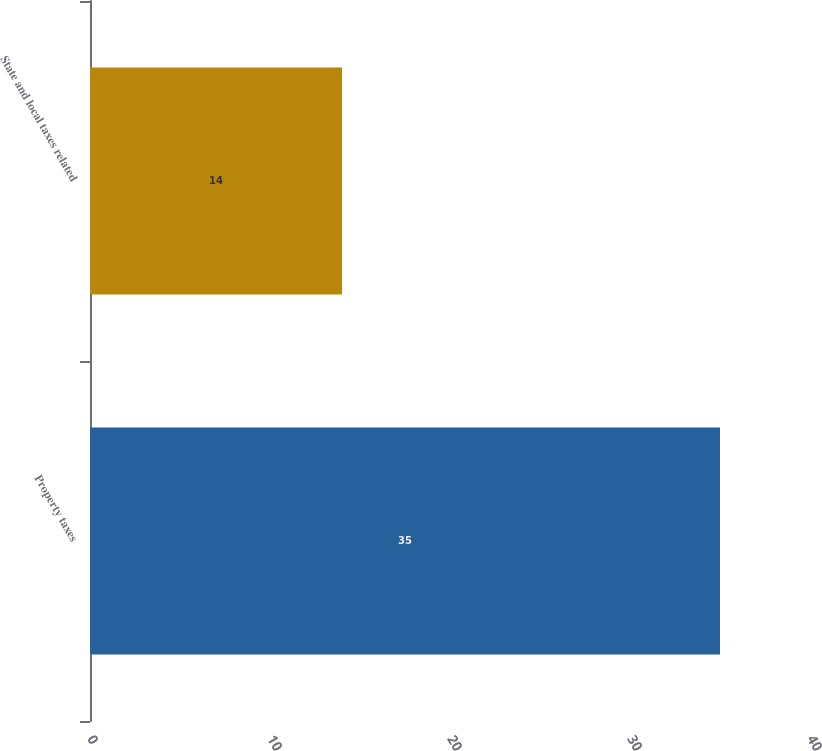Convert chart. <chart><loc_0><loc_0><loc_500><loc_500><bar_chart><fcel>Property taxes<fcel>State and local taxes related<nl><fcel>35<fcel>14<nl></chart> 